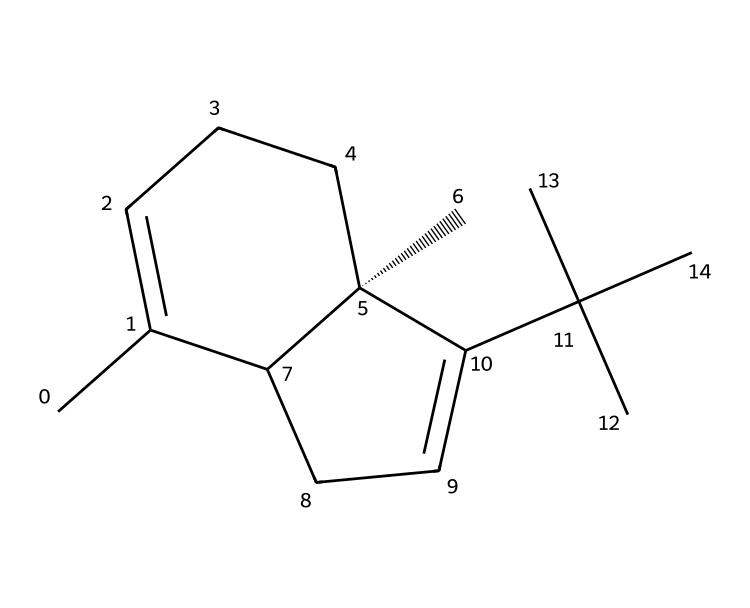what is the main functional group in caryophyllene? Caryophyllene consists of a carbon skeleton with double bonds, which are indicative of alkenes in its structure. There are no other prominent functional groups such as -OH or -COOH present.
Answer: alkene how many carbon atoms are in caryophyllene? By analyzing the SMILES representation, we can count each "C" in the structure, which shows that caryophyllene contains 15 carbon atoms.
Answer: 15 how many double bonds are present in caryophyllene? Observing the SMILES representation, there are two distinct sections where the double bonds occur. This leads us to conclude that there are two double bonds present in the structure.
Answer: 2 is caryophyllene a saturated or unsaturated compound? The presence of double bonds in caryophyllene indicates that it is not fully saturated with hydrogen atoms, which corresponds to it being an unsaturated compound.
Answer: unsaturated what structural feature identifies caryophyllene as a terpene? Caryophyllene features a bicyclic structure composed of five-membered rings and has multiple isoprene units, which are characteristic indicators of terpenes.
Answer: bicyclic structure 